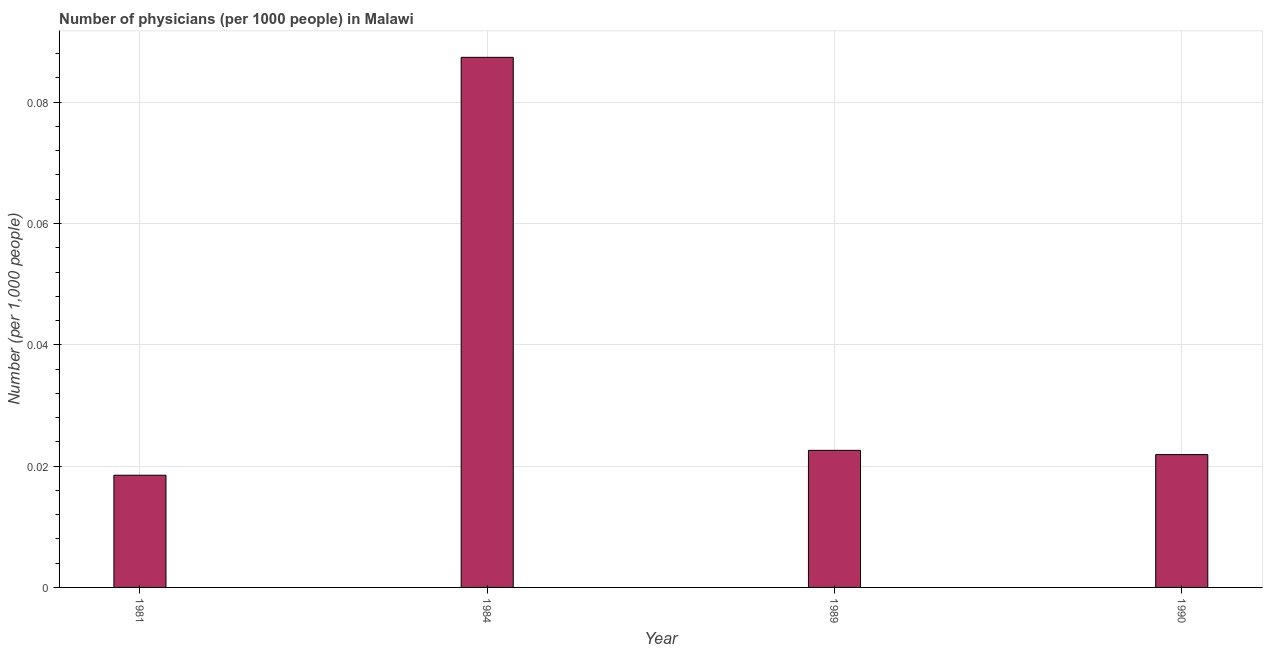What is the title of the graph?
Offer a very short reply. Number of physicians (per 1000 people) in Malawi. What is the label or title of the Y-axis?
Your response must be concise. Number (per 1,0 people). What is the number of physicians in 1984?
Offer a very short reply. 0.09. Across all years, what is the maximum number of physicians?
Offer a very short reply. 0.09. Across all years, what is the minimum number of physicians?
Ensure brevity in your answer.  0.02. What is the sum of the number of physicians?
Make the answer very short. 0.15. What is the average number of physicians per year?
Give a very brief answer. 0.04. What is the median number of physicians?
Your answer should be very brief. 0.02. What is the ratio of the number of physicians in 1984 to that in 1990?
Offer a terse response. 3.99. Is the number of physicians in 1984 less than that in 1989?
Your response must be concise. No. What is the difference between the highest and the second highest number of physicians?
Give a very brief answer. 0.07. What is the difference between the highest and the lowest number of physicians?
Make the answer very short. 0.07. Are all the bars in the graph horizontal?
Your answer should be compact. No. How many years are there in the graph?
Offer a very short reply. 4. What is the Number (per 1,000 people) in 1981?
Give a very brief answer. 0.02. What is the Number (per 1,000 people) of 1984?
Your answer should be compact. 0.09. What is the Number (per 1,000 people) of 1989?
Your answer should be very brief. 0.02. What is the Number (per 1,000 people) in 1990?
Your answer should be very brief. 0.02. What is the difference between the Number (per 1,000 people) in 1981 and 1984?
Keep it short and to the point. -0.07. What is the difference between the Number (per 1,000 people) in 1981 and 1989?
Your answer should be compact. -0. What is the difference between the Number (per 1,000 people) in 1981 and 1990?
Provide a short and direct response. -0. What is the difference between the Number (per 1,000 people) in 1984 and 1989?
Ensure brevity in your answer.  0.06. What is the difference between the Number (per 1,000 people) in 1984 and 1990?
Give a very brief answer. 0.07. What is the difference between the Number (per 1,000 people) in 1989 and 1990?
Give a very brief answer. 0. What is the ratio of the Number (per 1,000 people) in 1981 to that in 1984?
Your answer should be compact. 0.21. What is the ratio of the Number (per 1,000 people) in 1981 to that in 1989?
Offer a terse response. 0.82. What is the ratio of the Number (per 1,000 people) in 1981 to that in 1990?
Ensure brevity in your answer.  0.84. What is the ratio of the Number (per 1,000 people) in 1984 to that in 1989?
Provide a succinct answer. 3.87. What is the ratio of the Number (per 1,000 people) in 1984 to that in 1990?
Provide a short and direct response. 3.99. What is the ratio of the Number (per 1,000 people) in 1989 to that in 1990?
Your response must be concise. 1.03. 